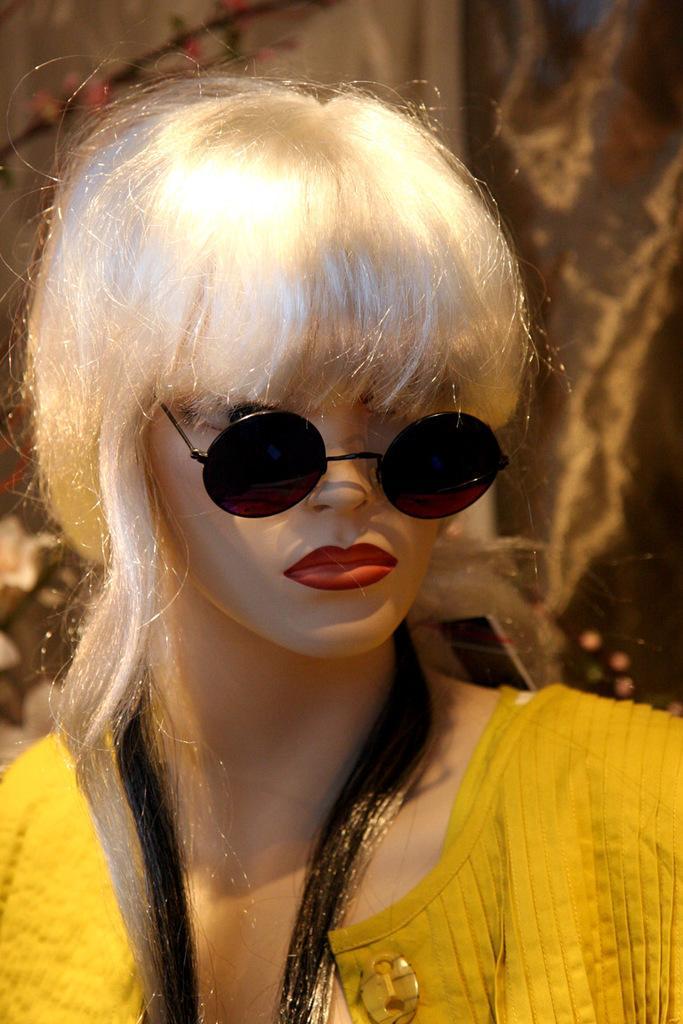Could you give a brief overview of what you see in this image? In this picture I can see a doll in the middle, this doll is wearing the dress and the goggles. 